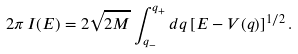<formula> <loc_0><loc_0><loc_500><loc_500>2 \pi \, I ( E ) = 2 \sqrt { 2 M } \int _ { q _ { - } } ^ { q _ { + } } d q \, [ E - V ( q ) ] ^ { 1 / 2 } \, .</formula> 